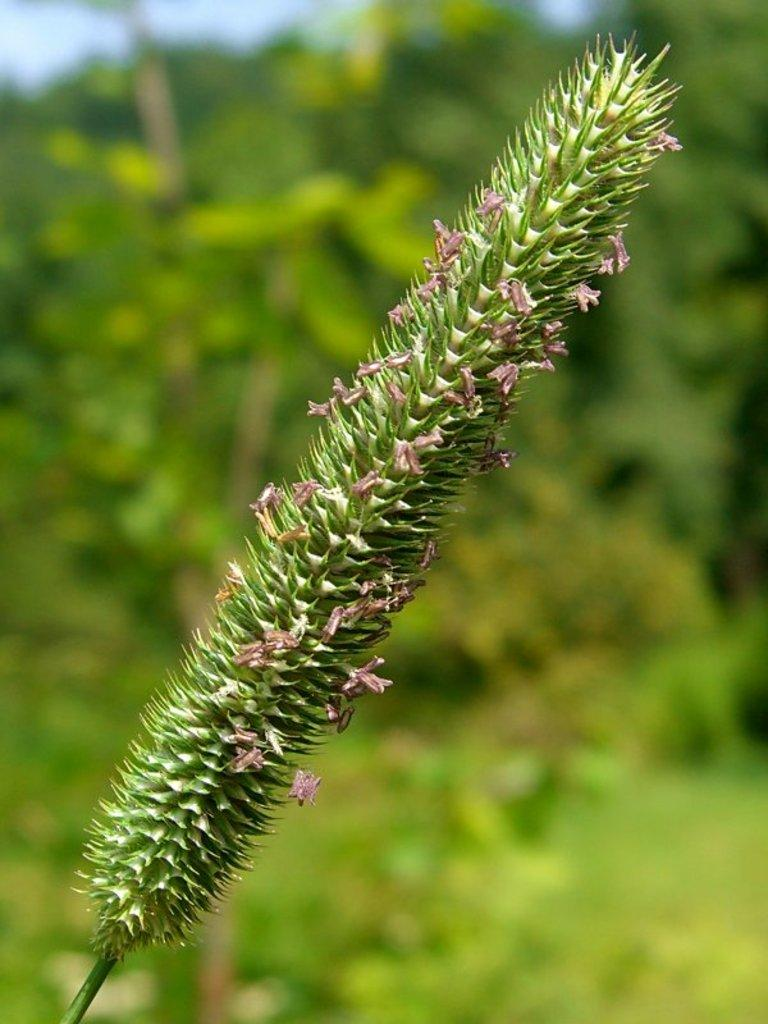What type of living organism can be seen in the image? There is a plant in the image. What can be seen in the background of the image? There is a group of trees and the sky visible in the background of the image. How many pizzas are hanging from the branches of the trees in the image? There are no pizzas present in the image; it features a plant and a group of trees. Can you see a robin perched on the plant in the image? There is no robin present in the image; it only features a plant and a group of trees. 